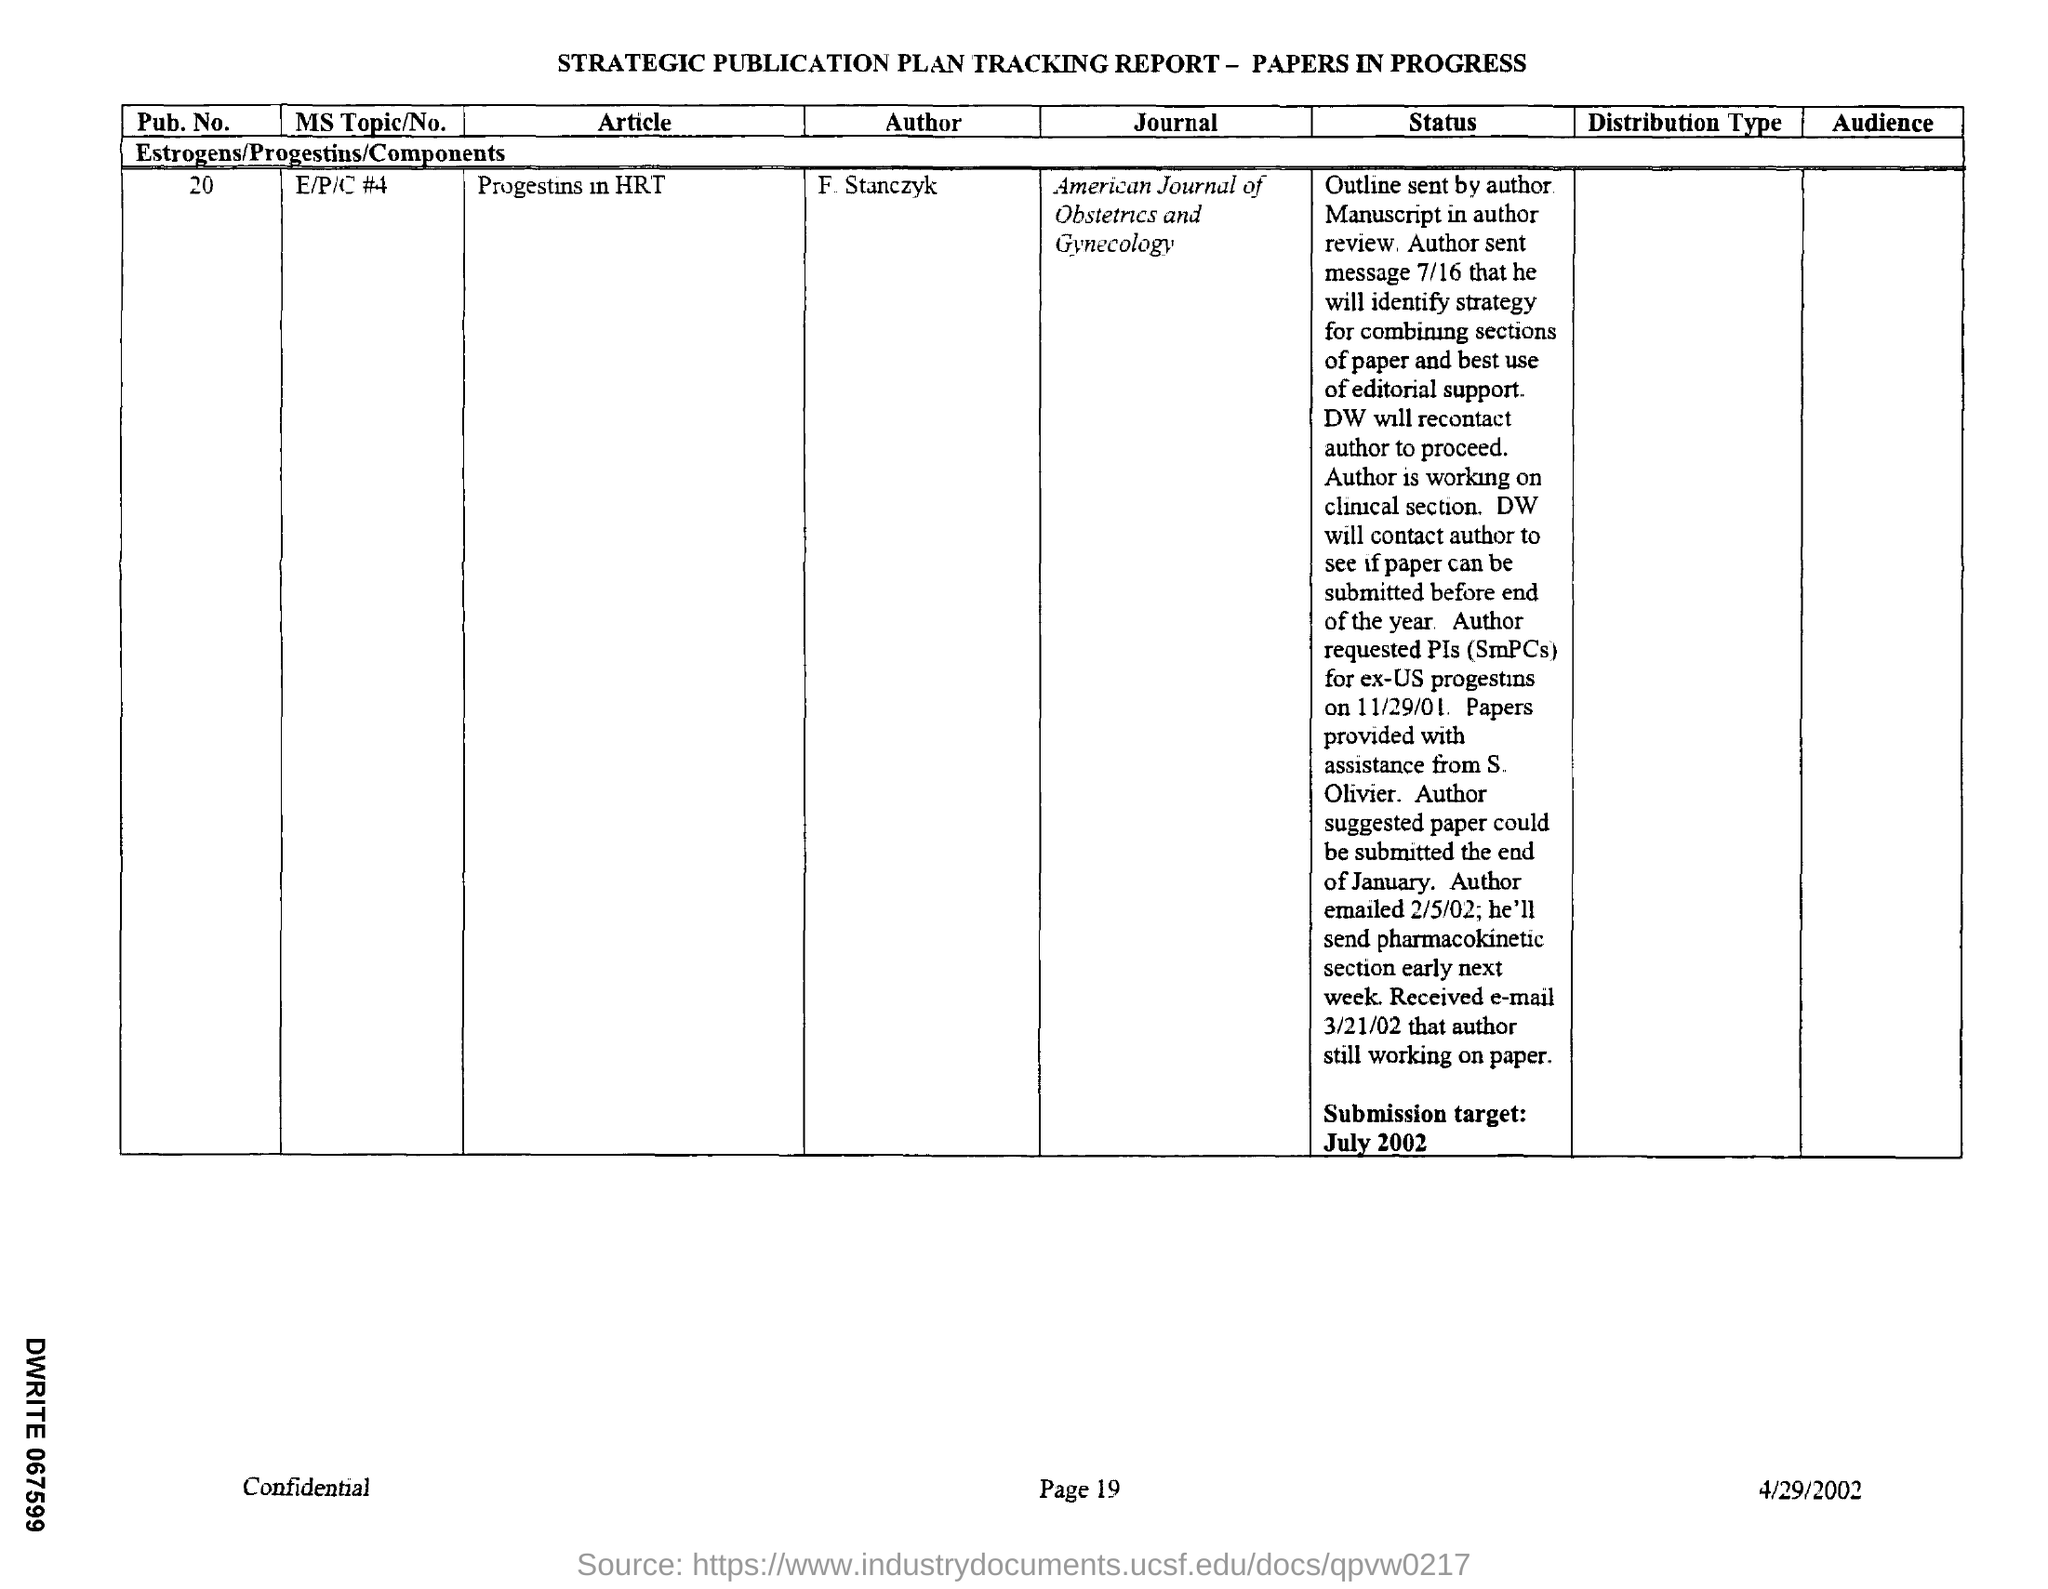Give some essential details in this illustration. The journal mentioned in the tracking report is the American Journal of Obstetrics and Gynecology. The article mentioned in the given report is titled 'progestins in HRT'. The MS Topic is not mentioned in the given report. The "pub .no." mentioned in the given tracking report is 20.. The given tracking report mentions an author named F. Stanczyk. 